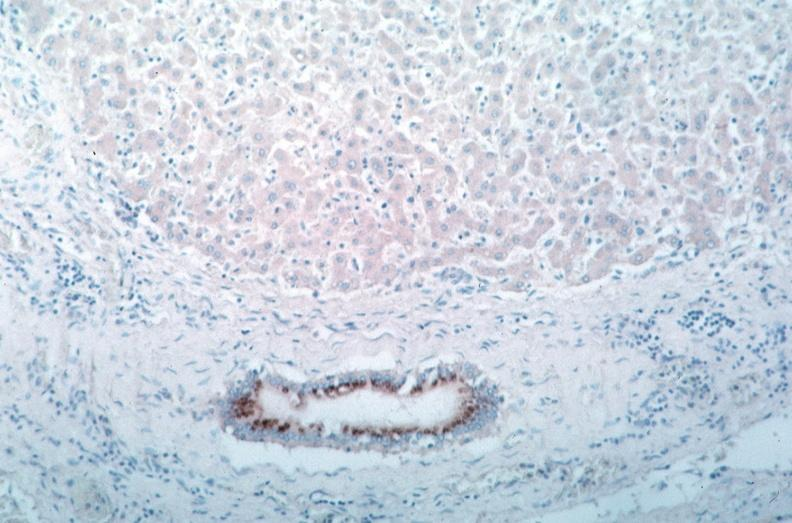what is present?
Answer the question using a single word or phrase. Cardiovascular 